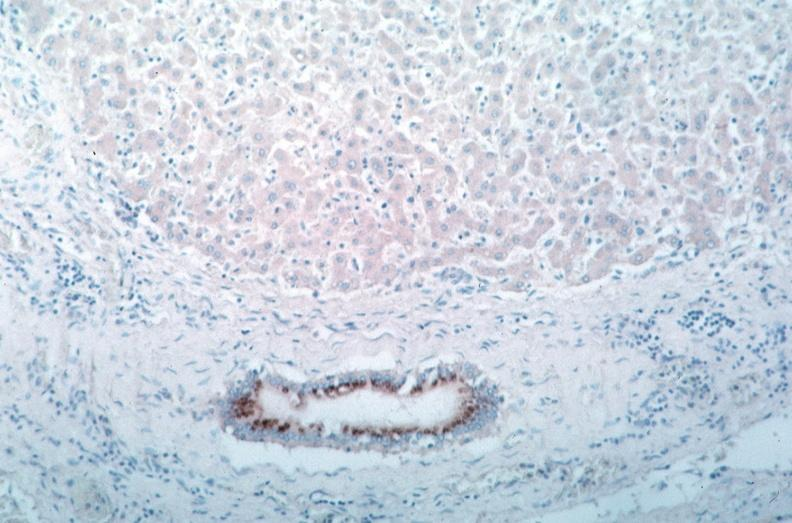what is present?
Answer the question using a single word or phrase. Cardiovascular 